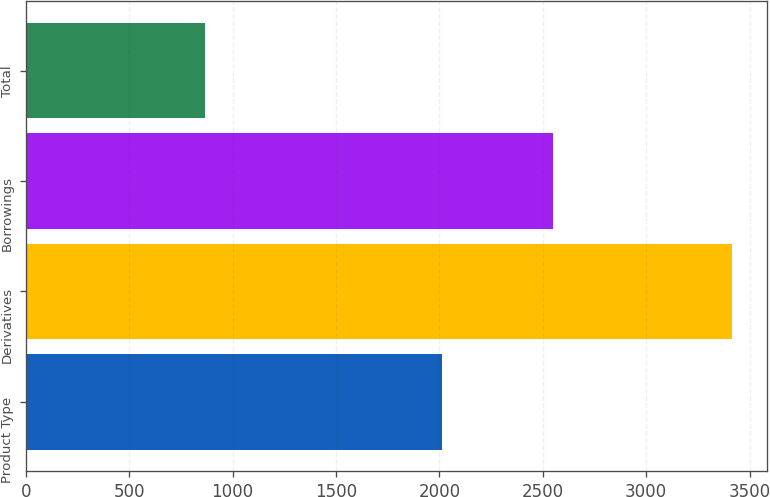Convert chart. <chart><loc_0><loc_0><loc_500><loc_500><bar_chart><fcel>Product Type<fcel>Derivatives<fcel>Borrowings<fcel>Total<nl><fcel>2011<fcel>3415<fcel>2549<fcel>866<nl></chart> 